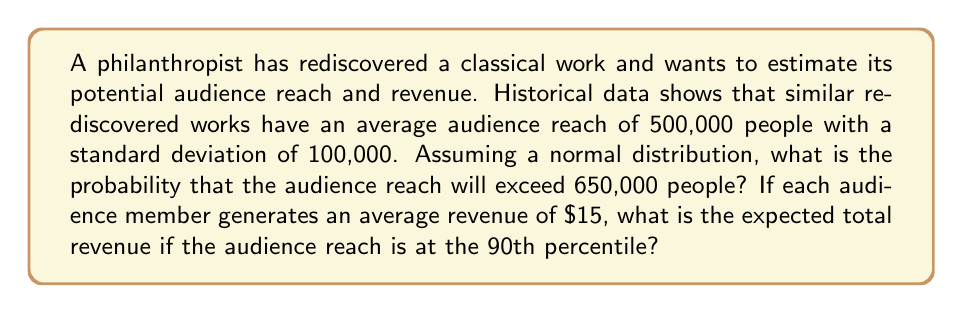Help me with this question. 1. To find the probability of exceeding 650,000 people, we need to calculate the z-score:

   $z = \frac{x - \mu}{\sigma} = \frac{650,000 - 500,000}{100,000} = 1.5$

2. Using a standard normal distribution table or calculator, we find:
   $P(Z > 1.5) \approx 0.0668$

3. To find the 90th percentile of audience reach, we use the inverse normal distribution:
   $z_{0.90} \approx 1.28$

4. Calculate the audience reach at the 90th percentile:
   $x = \mu + z\sigma = 500,000 + 1.28 \cdot 100,000 = 628,000$

5. Expected total revenue at 90th percentile:
   $\text{Revenue} = 628,000 \cdot \$15 = \$9,420,000$
Answer: Probability of exceeding 650,000: 6.68%. Expected revenue at 90th percentile: $9,420,000. 